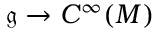Convert formula to latex. <formula><loc_0><loc_0><loc_500><loc_500>{ \mathfrak { g } } \to C ^ { \infty } ( M )</formula> 